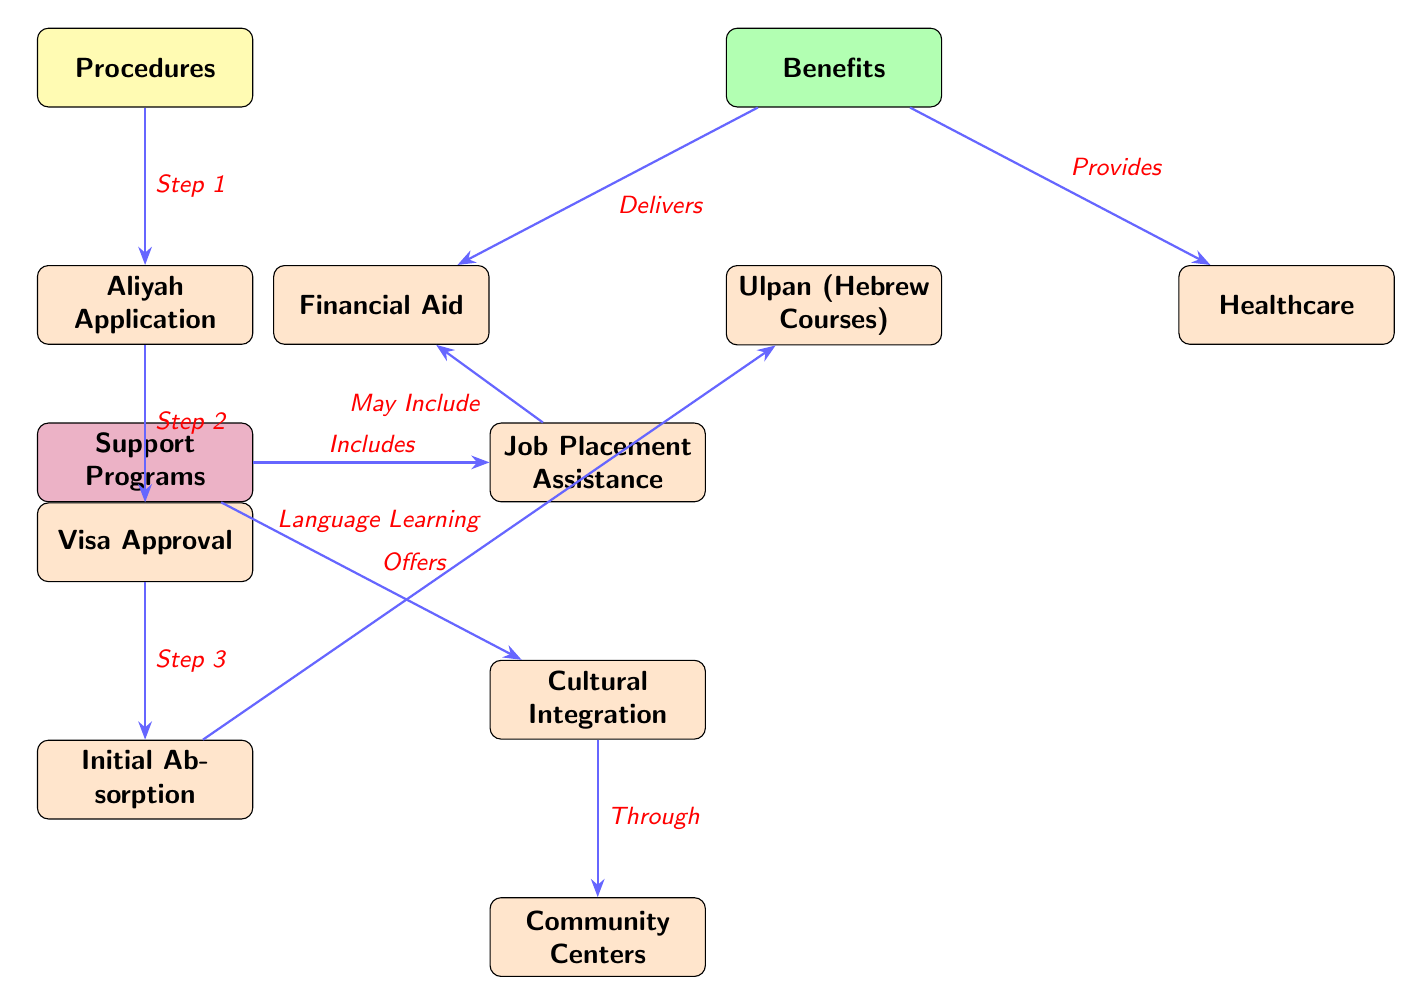What is the first step in the procedures? The first step in the procedures is labeled as "Step 1" leading to "Aliyah Application." This is directly indicated in the diagram.
Answer: Aliyah Application How many nodes are in the Support Programs section? In the Support Programs section, there are three nodes: "Job Placement Assistance," "Cultural Integration," and "Community Centers." This can be counted directly from the diagram.
Answer: 3 What benefit provides healthcare? The node labeled "Healthcare" is connected to the Benefits section and indicates that it is a specific benefit available to new immigrants.
Answer: Healthcare What follows Visa Approval in the Procedures? The step that follows "Visa Approval" is "Initial Absorption." This is indicated by the directed edge connecting these two nodes.
Answer: Initial Absorption What type of programs does "Cultural Integration" offer? "Cultural Integration" offers programs through "Community Centers," which is explicitly stated in the diagram showing the connection.
Answer: Community Centers What is the relationship between Job Placement Assistance and Financial Aid? The diagram shows that "Job Placement Assistance" may include "Financial Aid," as indicated by the directed edge and the quote. This reflects that there are possibilities of overlap in these services.
Answer: May Include How many edges are coming out of the Benefits node? There are three edges leading from the Benefits node: one towards "Financial Aid," one towards "Ulpan (Hebrew Courses)," and one towards "Healthcare." Counting these edges shows this connection.
Answer: 3 What is the last procedure in the chain of procedures? The last procedure in the flow is "Initial Absorption," which is the final node in the procedures sequence.
Answer: Initial Absorption What type of course is provided under Benefits? The type of course provided is "Ulpan (Hebrew Courses)," which specifically caters to language learning for immigrants.
Answer: Ulpan (Hebrew Courses) 